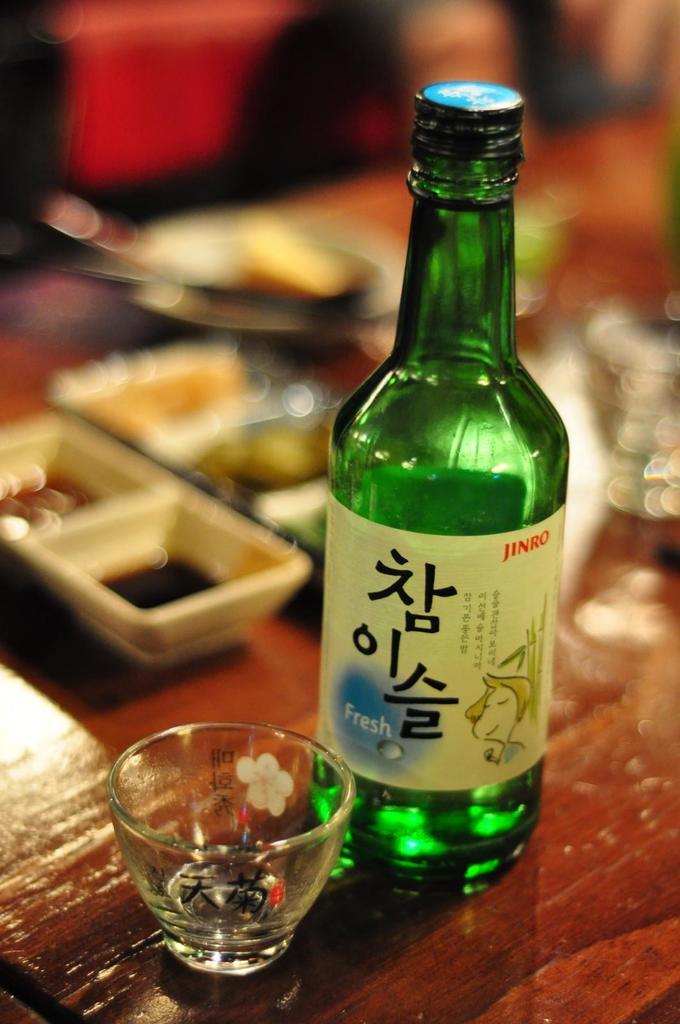Who makes the drink?
Give a very brief answer. Jinro. Is the drink fresh?
Your answer should be very brief. Yes. 